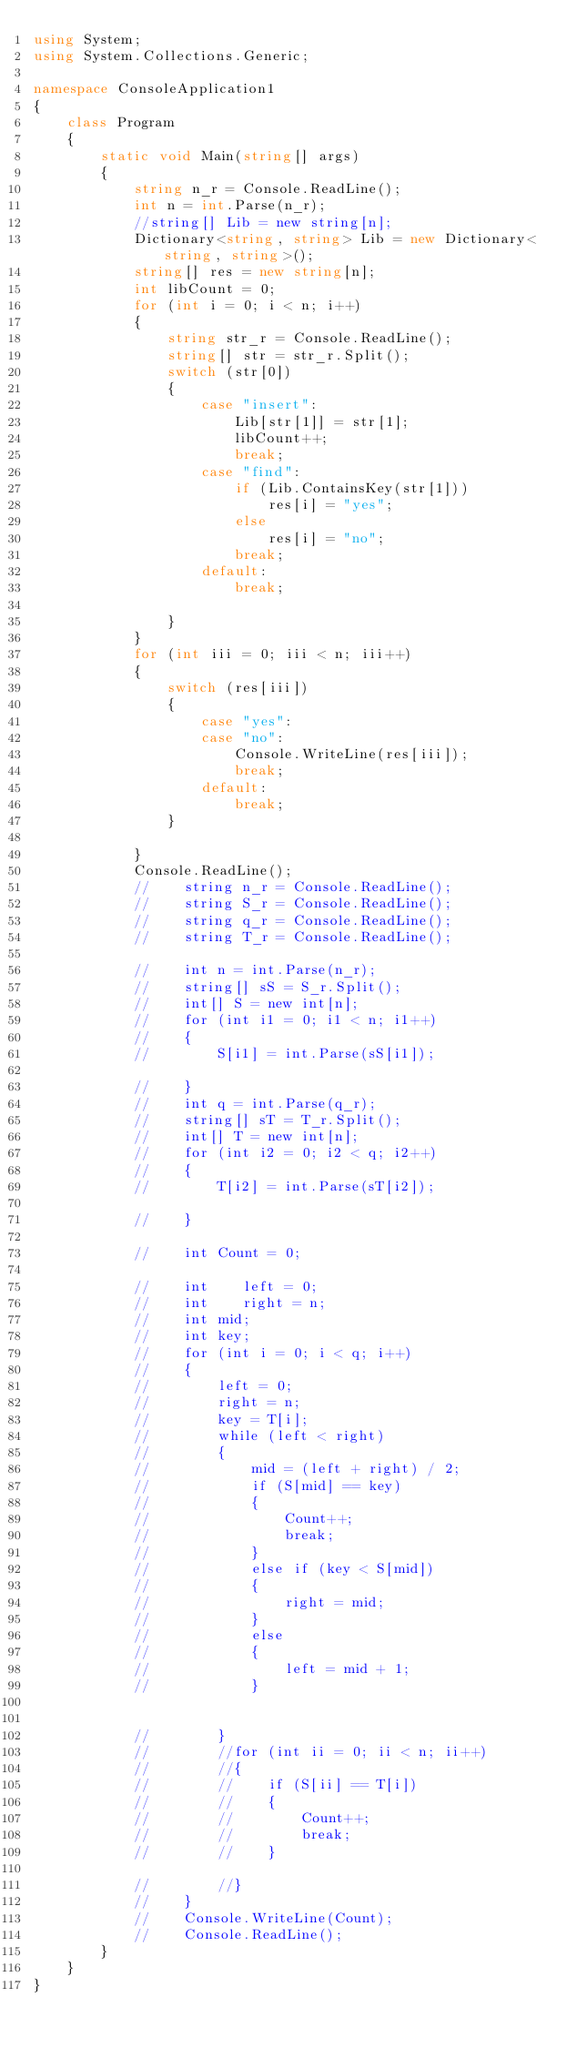Convert code to text. <code><loc_0><loc_0><loc_500><loc_500><_C#_>using System;
using System.Collections.Generic;

namespace ConsoleApplication1
{
    class Program
    {
        static void Main(string[] args)
        {
            string n_r = Console.ReadLine();
            int n = int.Parse(n_r);
            //string[] Lib = new string[n];
            Dictionary<string, string> Lib = new Dictionary<string, string>();
            string[] res = new string[n];
            int libCount = 0;
            for (int i = 0; i < n; i++)
            {
                string str_r = Console.ReadLine();
                string[] str = str_r.Split();
                switch (str[0])
                {
                    case "insert":
                        Lib[str[1]] = str[1];
                        libCount++;
                        break;
                    case "find":
                        if (Lib.ContainsKey(str[1]))
                            res[i] = "yes";
                        else
                            res[i] = "no";
                        break;
                    default:
                        break;

                }
            }
            for (int iii = 0; iii < n; iii++)
            {
                switch (res[iii])
                {
                    case "yes":
                    case "no":
                        Console.WriteLine(res[iii]);
                        break;
                    default:
                        break;
                }

            }
            Console.ReadLine();
            //    string n_r = Console.ReadLine();
            //    string S_r = Console.ReadLine();
            //    string q_r = Console.ReadLine();
            //    string T_r = Console.ReadLine();

            //    int n = int.Parse(n_r);
            //    string[] sS = S_r.Split();
            //    int[] S = new int[n];
            //    for (int i1 = 0; i1 < n; i1++)
            //    {
            //        S[i1] = int.Parse(sS[i1]);

            //    }
            //    int q = int.Parse(q_r);
            //    string[] sT = T_r.Split();
            //    int[] T = new int[n];
            //    for (int i2 = 0; i2 < q; i2++)
            //    {
            //        T[i2] = int.Parse(sT[i2]);

            //    }

            //    int Count = 0;

            //    int    left = 0;
            //    int    right = n;
            //    int mid;
            //    int key;
            //    for (int i = 0; i < q; i++)
            //    {
            //        left = 0;
            //        right = n;
            //        key = T[i];
            //        while (left < right)
            //        {
            //            mid = (left + right) / 2;
            //            if (S[mid] == key)
            //            {
            //                Count++;
            //                break;
            //            }
            //            else if (key < S[mid])
            //            {
            //                right = mid;
            //            }
            //            else
            //            {
            //                left = mid + 1;
            //            }


            //        }
            //        //for (int ii = 0; ii < n; ii++)
            //        //{
            //        //    if (S[ii] == T[i])
            //        //    {
            //        //        Count++;
            //        //        break;
            //        //    }

            //        //}
            //    }
            //    Console.WriteLine(Count);
            //    Console.ReadLine();
        }
    }
}</code> 